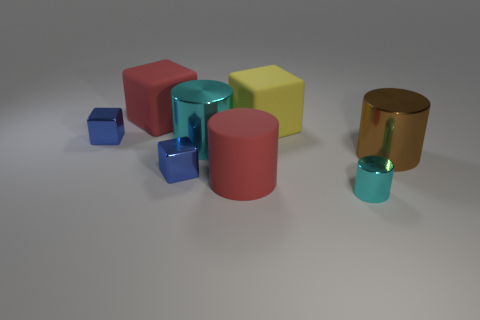Subtract all big yellow cubes. How many cubes are left? 3 Subtract 1 cylinders. How many cylinders are left? 3 Subtract all brown cylinders. How many cylinders are left? 3 Subtract all green cylinders. Subtract all red spheres. How many cylinders are left? 4 Add 2 large yellow matte balls. How many objects exist? 10 Subtract all large gray rubber things. Subtract all brown cylinders. How many objects are left? 7 Add 1 metal things. How many metal things are left? 6 Add 1 tiny red balls. How many tiny red balls exist? 1 Subtract 0 purple spheres. How many objects are left? 8 